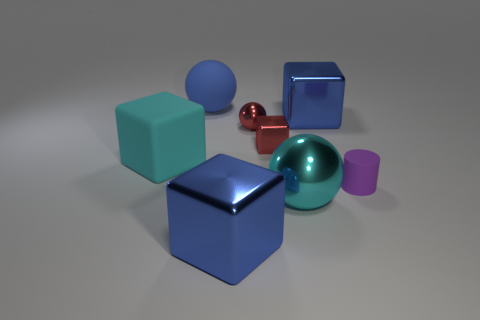What textures are present on the objects? There are at least two distinct textures visible: a smooth or glossy texture on the red sphere and the blue cubes, and a matte finish on the cyan and magenta cubes and the magenta cylinder. 